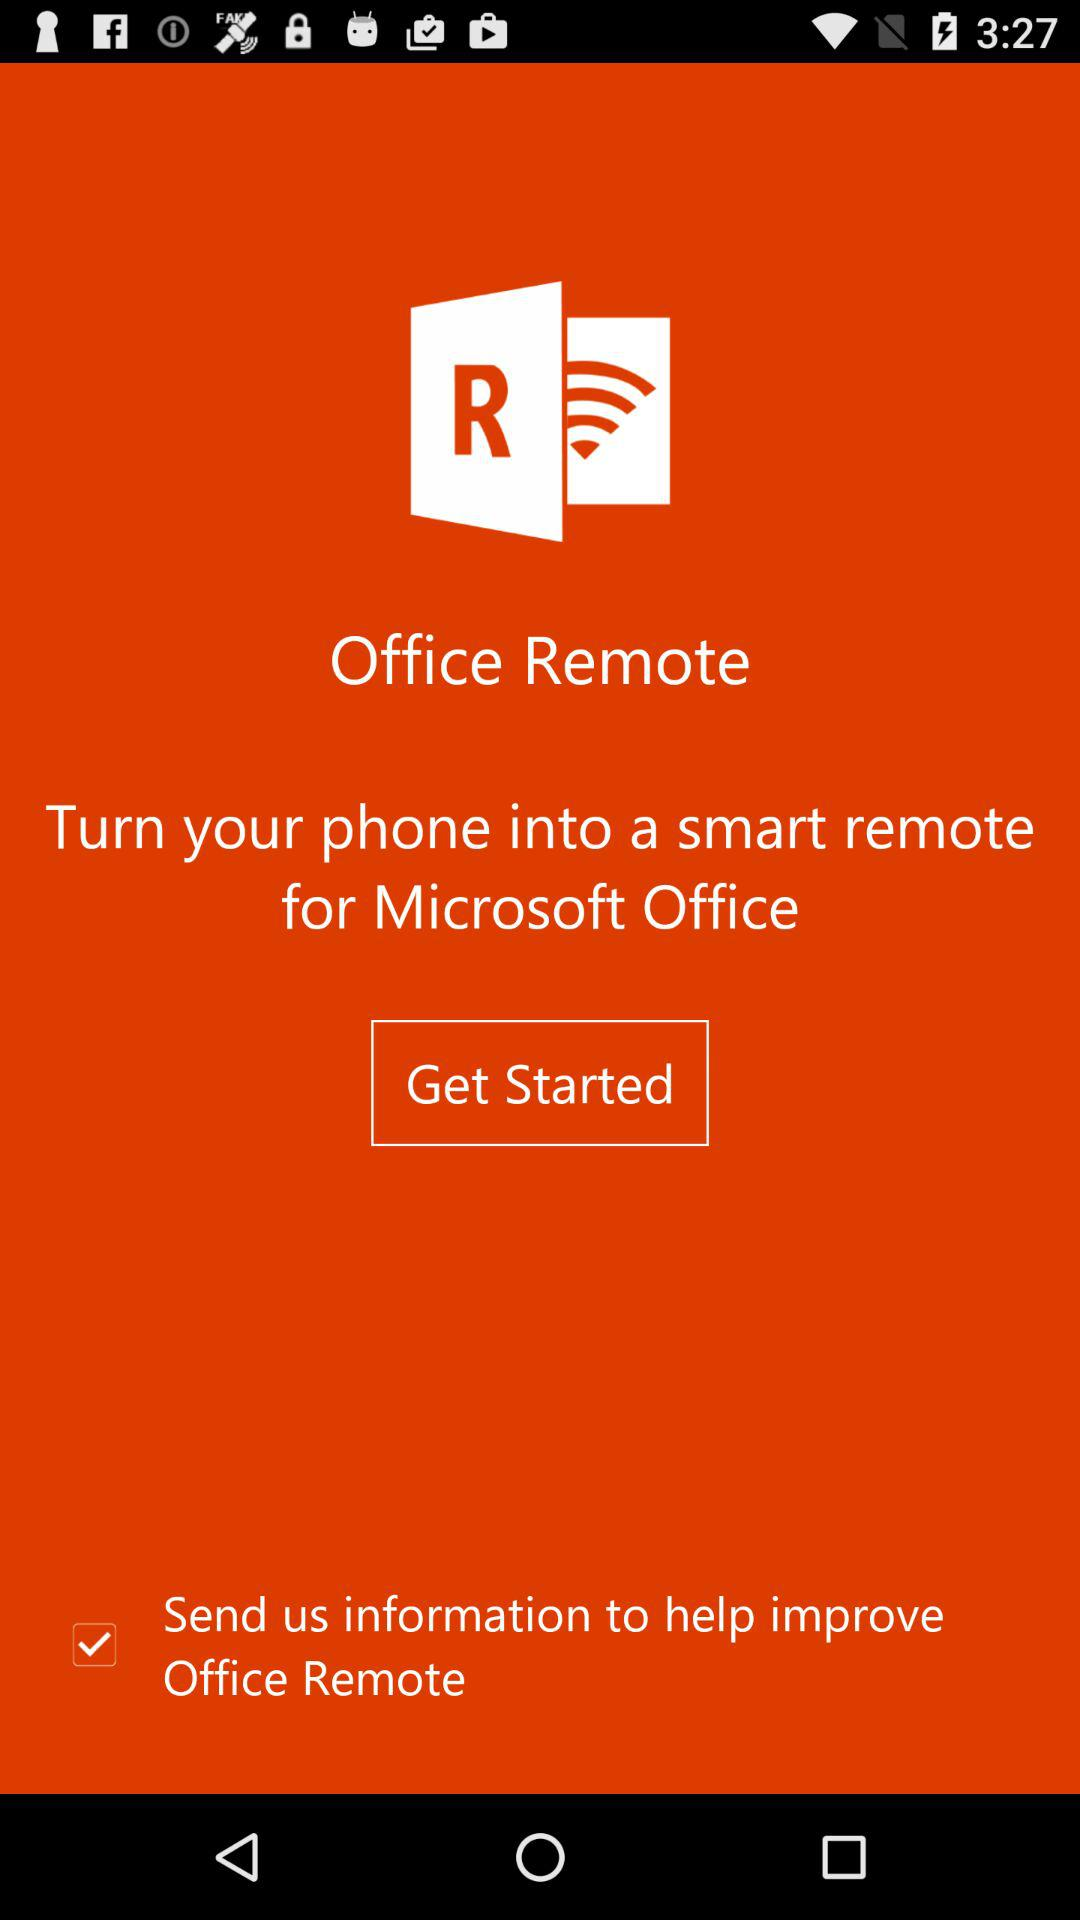What is the application name? The application name is "Office Remote". 